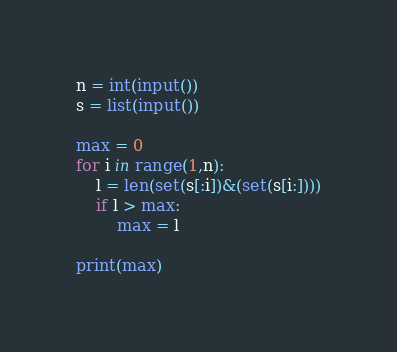<code> <loc_0><loc_0><loc_500><loc_500><_Python_>n = int(input())
s = list(input())

max = 0
for i in range(1,n):
    l = len(set(s[:i])&(set(s[i:])))
    if l > max:
        max = l

print(max)</code> 